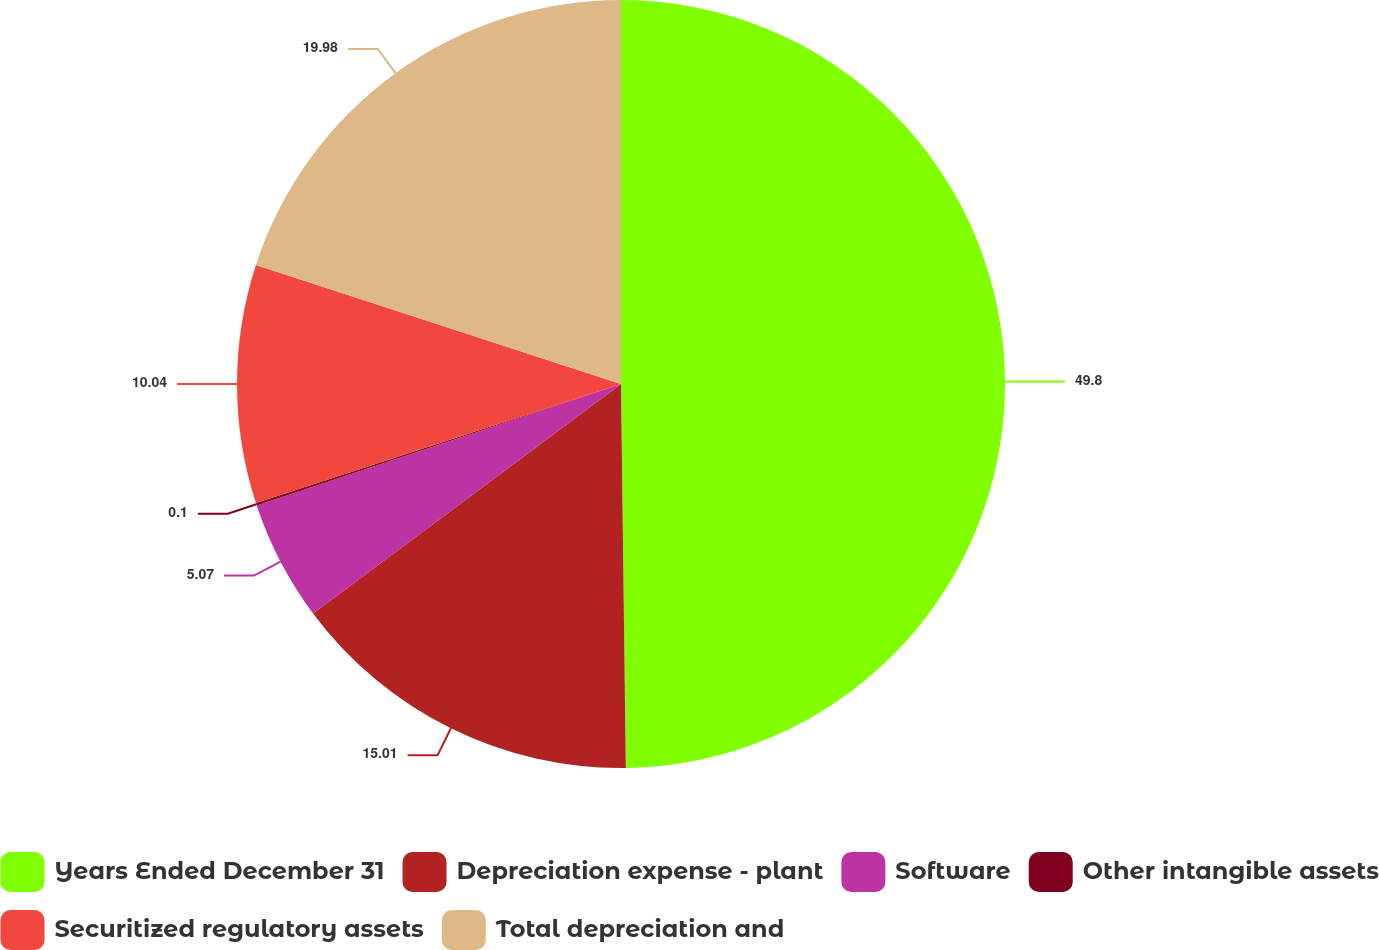Convert chart to OTSL. <chart><loc_0><loc_0><loc_500><loc_500><pie_chart><fcel>Years Ended December 31<fcel>Depreciation expense - plant<fcel>Software<fcel>Other intangible assets<fcel>Securitized regulatory assets<fcel>Total depreciation and<nl><fcel>49.8%<fcel>15.01%<fcel>5.07%<fcel>0.1%<fcel>10.04%<fcel>19.98%<nl></chart> 